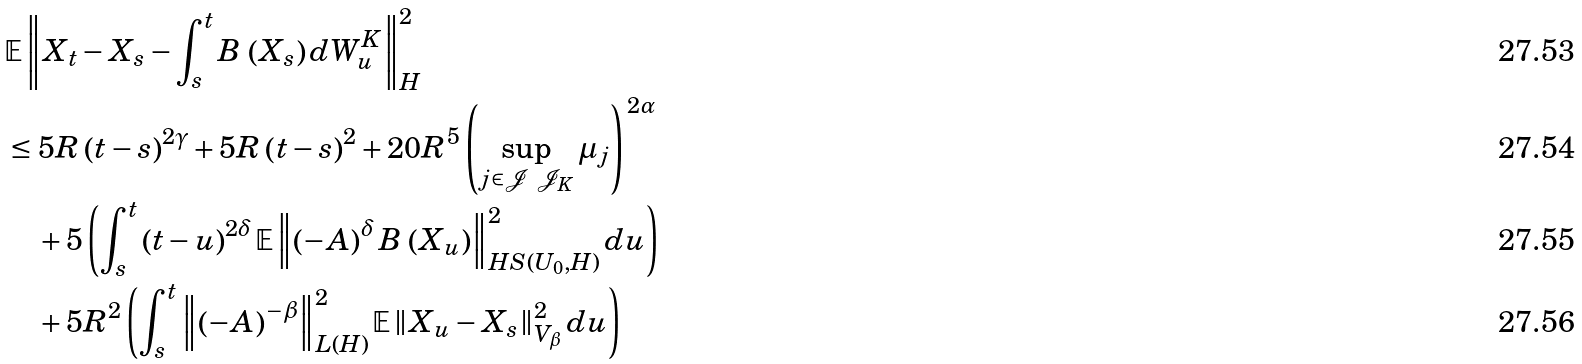<formula> <loc_0><loc_0><loc_500><loc_500>& \mathbb { E } \left \| X _ { t } - X _ { s } - \int _ { s } ^ { t } B \, \left ( X _ { s } \right ) d W _ { u } ^ { K } \right \| _ { H } ^ { 2 } \\ & \leq 5 R \left ( t - s \right ) ^ { 2 \gamma } + 5 R \left ( t - s \right ) ^ { 2 } + 2 0 R ^ { 5 } \left ( \sup _ { j \in \mathcal { J } \ \mathcal { J } _ { K } } \mu _ { j } \right ) ^ { \, 2 \alpha } \\ & \quad + 5 \left ( \int _ { s } ^ { t } \left ( t - u \right ) ^ { 2 \delta } \mathbb { E } \left \| \left ( - A \right ) ^ { \delta } B \, \left ( X _ { u } \right ) \right \| _ { H S ( U _ { 0 } , H ) } ^ { 2 } d u \right ) \\ & \quad + 5 R ^ { 2 } \left ( \int _ { s } ^ { t } \left \| \left ( - A \right ) ^ { - \beta } \right \| _ { L ( H ) } ^ { 2 } \mathbb { E } \left \| X _ { u } - X _ { s } \right \| _ { V _ { \beta } } ^ { 2 } d u \right )</formula> 